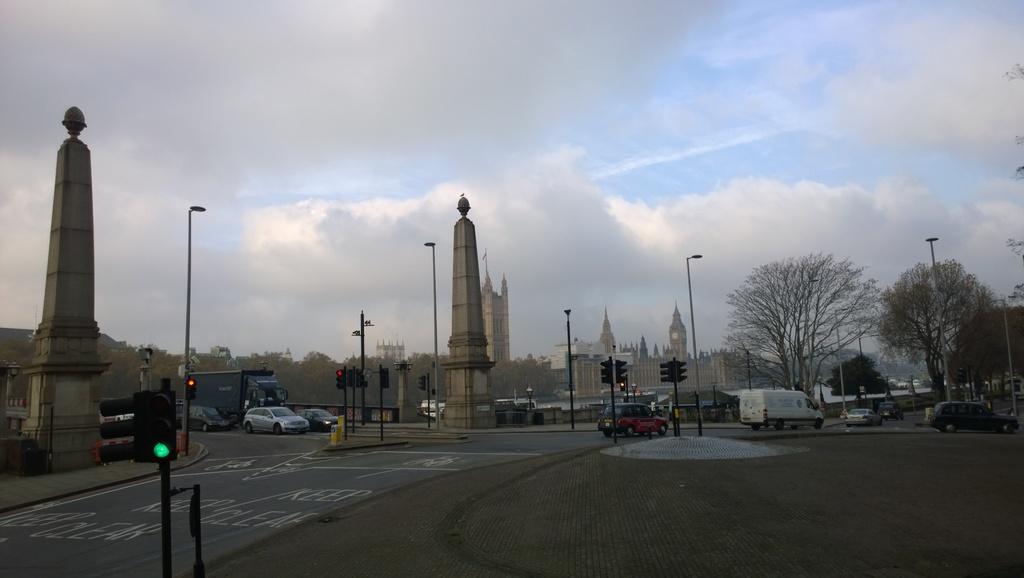Can you describe this image briefly? There are vehicles on the road. Here we can see poles, trees, buildings, and traffic signals. In the background there is sky with clouds. 